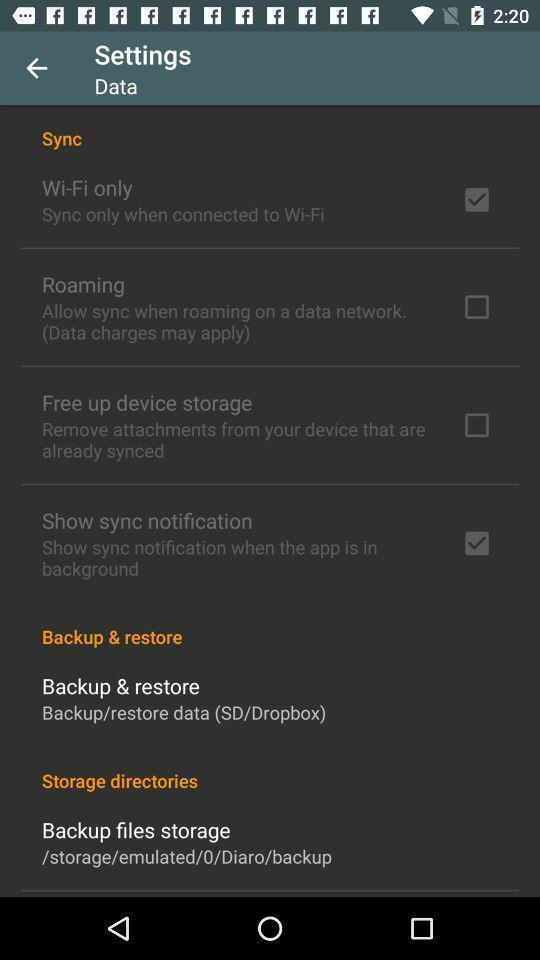Describe the visual elements of this screenshot. Settings tab with different options in the application. 